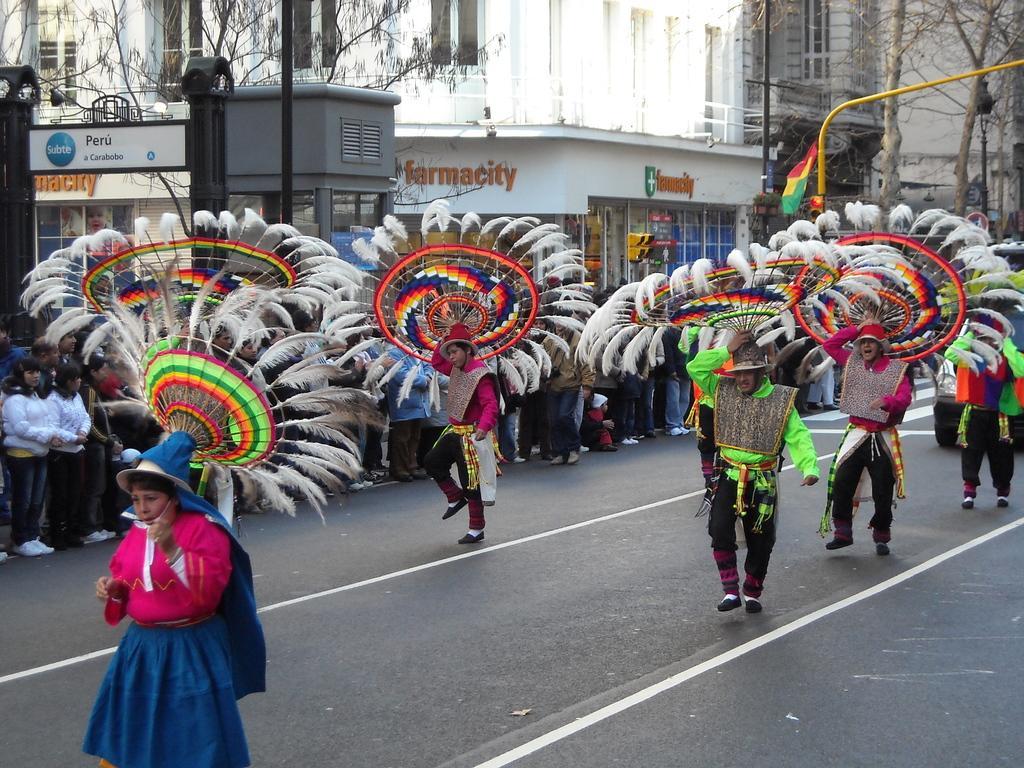Describe this image in one or two sentences. In this image I can see at the bottom few persons are walking on the road by wearing the costumes. In the middle a group of people are standing and looking at them, in the background there are trees and buildings. 